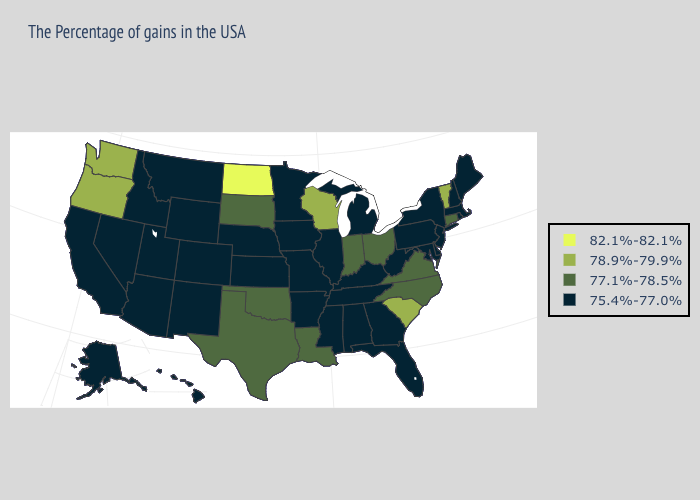What is the highest value in the USA?
Answer briefly. 82.1%-82.1%. Which states have the highest value in the USA?
Answer briefly. North Dakota. Does the first symbol in the legend represent the smallest category?
Give a very brief answer. No. Which states have the lowest value in the MidWest?
Be succinct. Michigan, Illinois, Missouri, Minnesota, Iowa, Kansas, Nebraska. Name the states that have a value in the range 82.1%-82.1%?
Quick response, please. North Dakota. Does New Mexico have the same value as Virginia?
Answer briefly. No. What is the value of Maine?
Be succinct. 75.4%-77.0%. Name the states that have a value in the range 82.1%-82.1%?
Be succinct. North Dakota. What is the lowest value in the USA?
Give a very brief answer. 75.4%-77.0%. Which states have the highest value in the USA?
Quick response, please. North Dakota. What is the value of Montana?
Give a very brief answer. 75.4%-77.0%. What is the value of Virginia?
Keep it brief. 77.1%-78.5%. Does Nevada have the highest value in the USA?
Quick response, please. No. Does Washington have the highest value in the West?
Give a very brief answer. Yes. Does Kansas have the highest value in the USA?
Write a very short answer. No. 